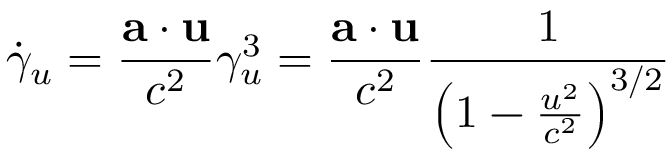Convert formula to latex. <formula><loc_0><loc_0><loc_500><loc_500>{ \dot { \gamma } } _ { u } = { \frac { a \cdot u } { c ^ { 2 } } } \gamma _ { u } ^ { 3 } = { \frac { a \cdot u } { c ^ { 2 } } } { \frac { 1 } { \left ( 1 - { \frac { u ^ { 2 } } { c ^ { 2 } } } \right ) ^ { 3 / 2 } } }</formula> 